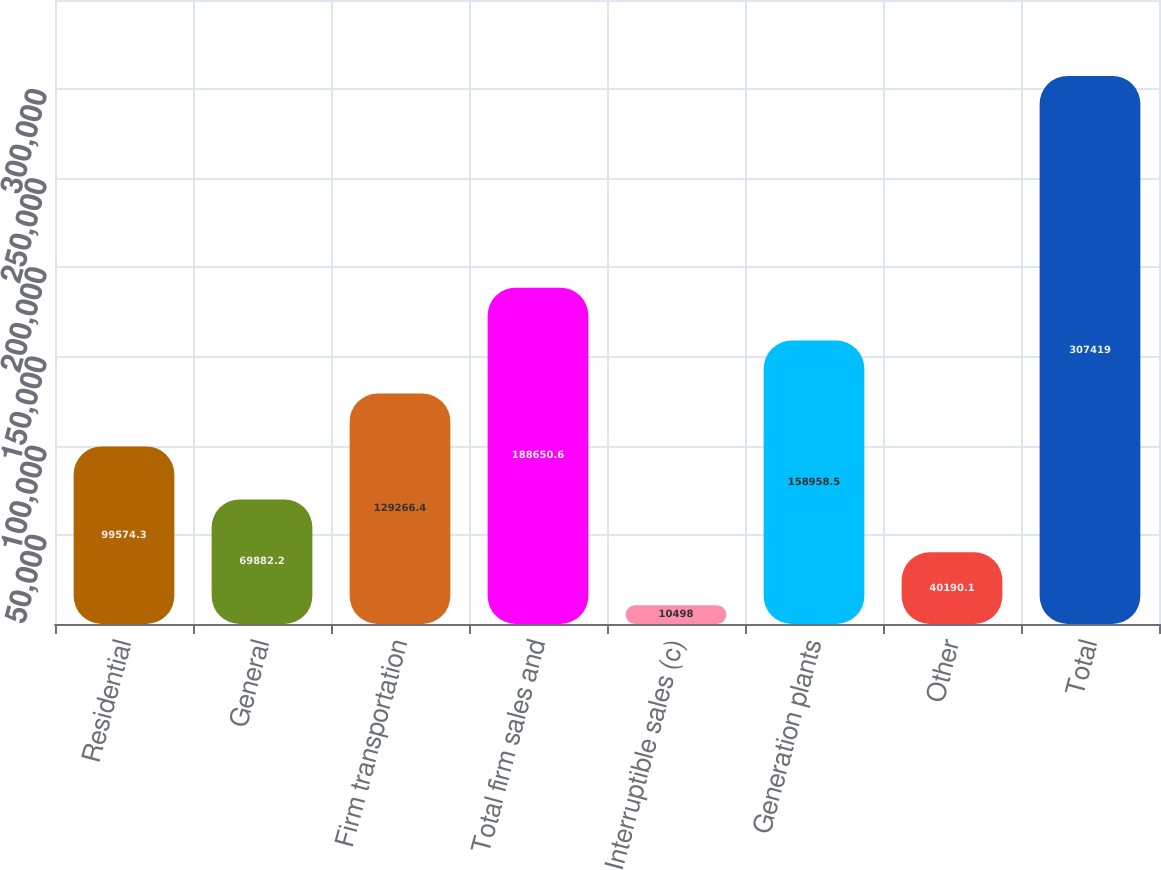Convert chart. <chart><loc_0><loc_0><loc_500><loc_500><bar_chart><fcel>Residential<fcel>General<fcel>Firm transportation<fcel>Total firm sales and<fcel>Interruptible sales (c)<fcel>Generation plants<fcel>Other<fcel>Total<nl><fcel>99574.3<fcel>69882.2<fcel>129266<fcel>188651<fcel>10498<fcel>158958<fcel>40190.1<fcel>307419<nl></chart> 